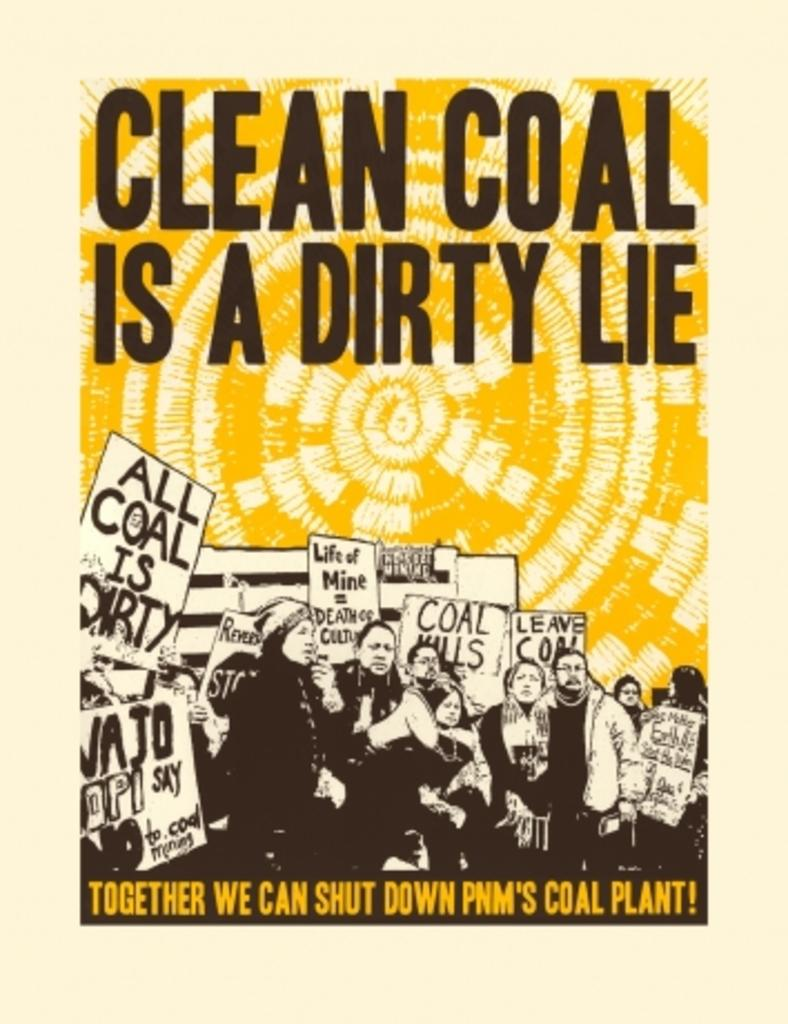<image>
Share a concise interpretation of the image provided. The protesters on the front of the book claim that all coal is dirty. 